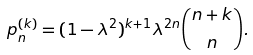Convert formula to latex. <formula><loc_0><loc_0><loc_500><loc_500>p _ { n } ^ { ( k ) } = ( 1 - \lambda ^ { 2 } ) ^ { k + 1 } \lambda ^ { 2 n } \binom { n + k } { n } .</formula> 